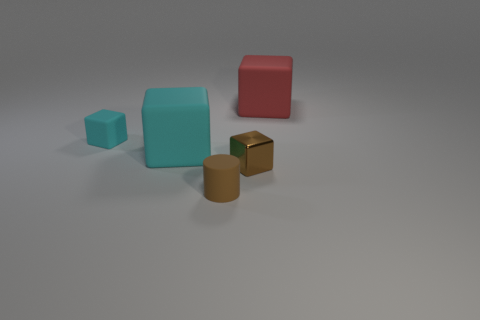Are there fewer cyan matte objects in front of the brown matte thing than matte cubes that are to the right of the shiny block?
Keep it short and to the point. Yes. There is a shiny thing; is it the same shape as the tiny rubber thing that is on the left side of the rubber cylinder?
Make the answer very short. Yes. Is there a tiny cyan object of the same shape as the brown metallic object?
Your response must be concise. Yes. What shape is the brown rubber object that is the same size as the metallic block?
Your answer should be compact. Cylinder. Is the matte cylinder the same color as the metallic block?
Your answer should be compact. Yes. There is a object in front of the brown metallic block; how big is it?
Offer a terse response. Small. There is a large block behind the tiny rubber object that is to the left of the small brown thing that is to the left of the tiny brown metal cube; what color is it?
Keep it short and to the point. Red. There is a large object that is to the left of the brown cylinder; is its color the same as the small matte cube?
Ensure brevity in your answer.  Yes. How many brown things are both to the right of the brown rubber cylinder and on the left side of the tiny brown shiny object?
Your answer should be compact. 0. What is the size of the red object that is the same shape as the tiny brown metallic object?
Offer a terse response. Large. 